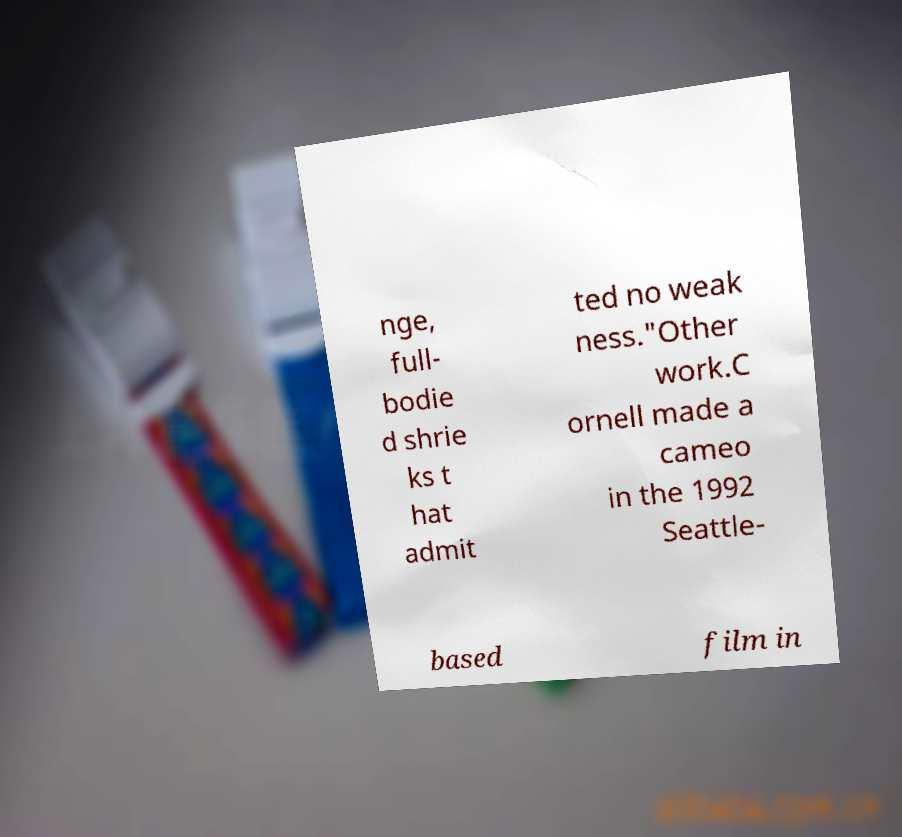What messages or text are displayed in this image? I need them in a readable, typed format. nge, full- bodie d shrie ks t hat admit ted no weak ness."Other work.C ornell made a cameo in the 1992 Seattle- based film in 